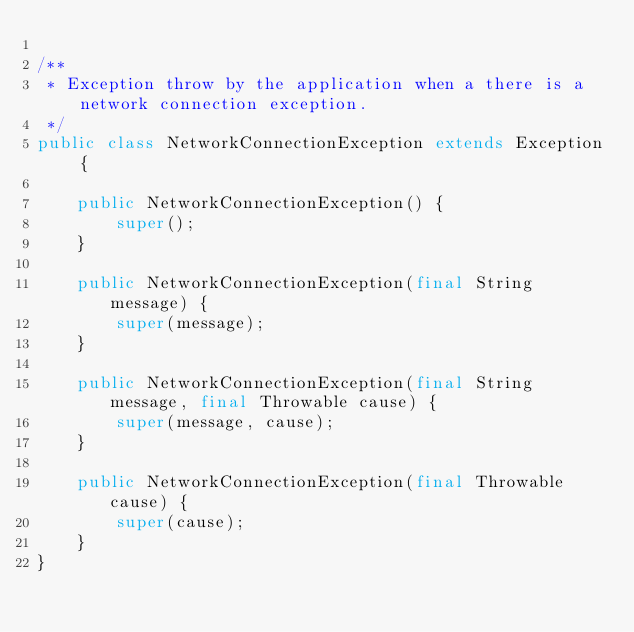Convert code to text. <code><loc_0><loc_0><loc_500><loc_500><_Java_>
/**
 * Exception throw by the application when a there is a network connection exception.
 */
public class NetworkConnectionException extends Exception {

    public NetworkConnectionException() {
        super();
    }

    public NetworkConnectionException(final String message) {
        super(message);
    }

    public NetworkConnectionException(final String message, final Throwable cause) {
        super(message, cause);
    }

    public NetworkConnectionException(final Throwable cause) {
        super(cause);
    }
}
</code> 